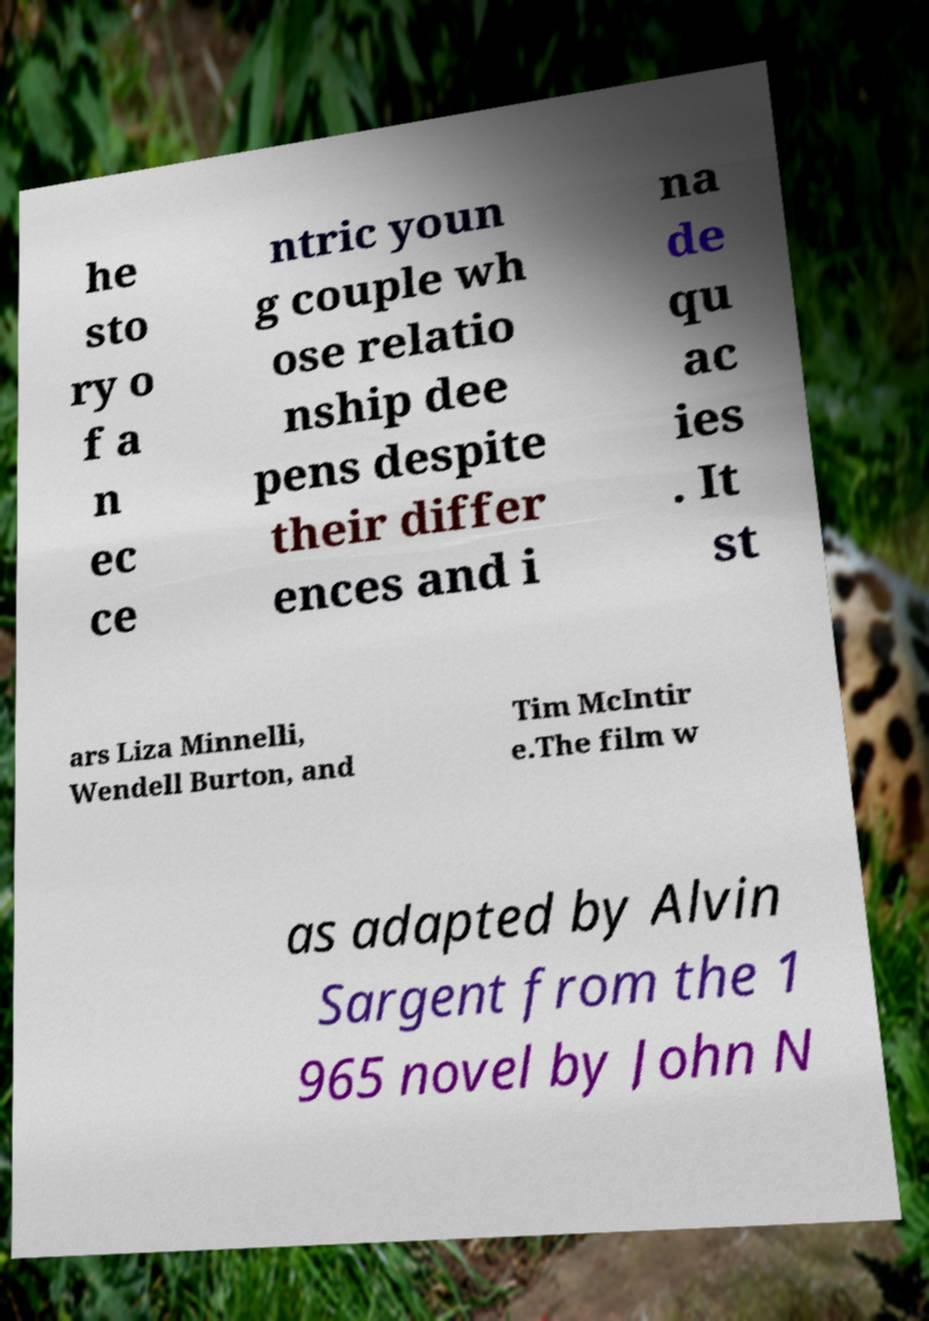Could you assist in decoding the text presented in this image and type it out clearly? he sto ry o f a n ec ce ntric youn g couple wh ose relatio nship dee pens despite their differ ences and i na de qu ac ies . It st ars Liza Minnelli, Wendell Burton, and Tim McIntir e.The film w as adapted by Alvin Sargent from the 1 965 novel by John N 